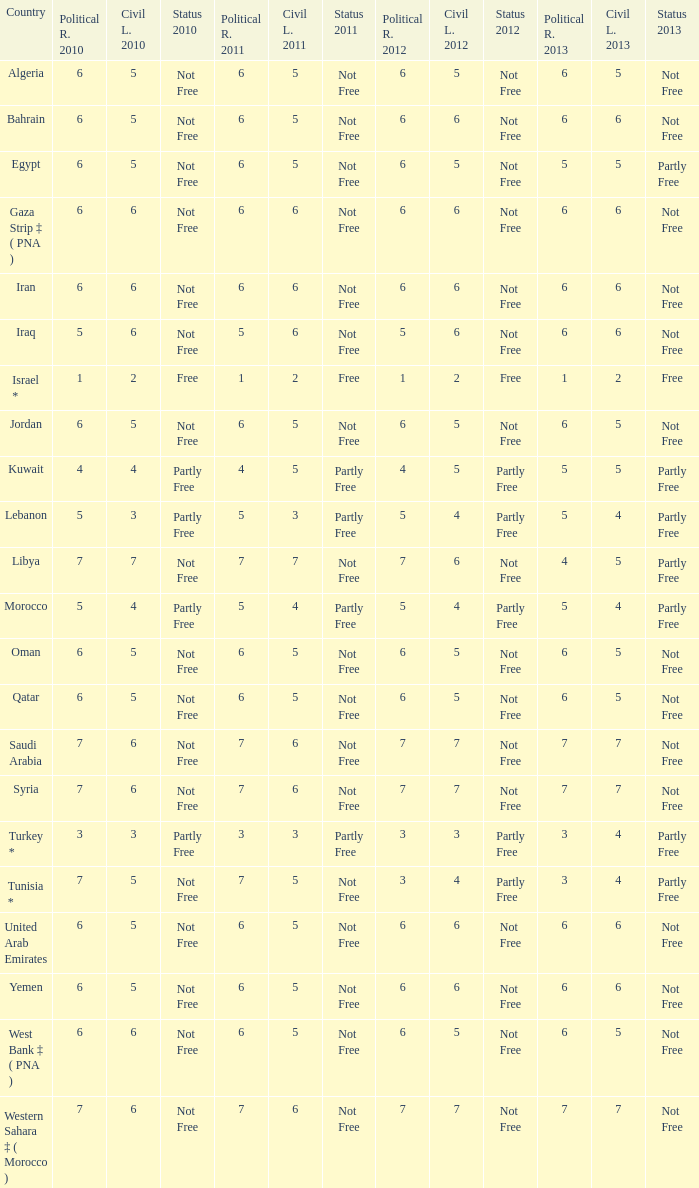What is the average 2012 civil liberties value associated with a 2011 status of not free, political rights 2012 over 6, and political rights 2011 over 7? None. Would you be able to parse every entry in this table? {'header': ['Country', 'Political R. 2010', 'Civil L. 2010', 'Status 2010', 'Political R. 2011', 'Civil L. 2011', 'Status 2011', 'Political R. 2012', 'Civil L. 2012', 'Status 2012', 'Political R. 2013', 'Civil L. 2013', 'Status 2013'], 'rows': [['Algeria', '6', '5', 'Not Free', '6', '5', 'Not Free', '6', '5', 'Not Free', '6', '5', 'Not Free'], ['Bahrain', '6', '5', 'Not Free', '6', '5', 'Not Free', '6', '6', 'Not Free', '6', '6', 'Not Free'], ['Egypt', '6', '5', 'Not Free', '6', '5', 'Not Free', '6', '5', 'Not Free', '5', '5', 'Partly Free'], ['Gaza Strip ‡ ( PNA )', '6', '6', 'Not Free', '6', '6', 'Not Free', '6', '6', 'Not Free', '6', '6', 'Not Free'], ['Iran', '6', '6', 'Not Free', '6', '6', 'Not Free', '6', '6', 'Not Free', '6', '6', 'Not Free'], ['Iraq', '5', '6', 'Not Free', '5', '6', 'Not Free', '5', '6', 'Not Free', '6', '6', 'Not Free'], ['Israel *', '1', '2', 'Free', '1', '2', 'Free', '1', '2', 'Free', '1', '2', 'Free'], ['Jordan', '6', '5', 'Not Free', '6', '5', 'Not Free', '6', '5', 'Not Free', '6', '5', 'Not Free'], ['Kuwait', '4', '4', 'Partly Free', '4', '5', 'Partly Free', '4', '5', 'Partly Free', '5', '5', 'Partly Free'], ['Lebanon', '5', '3', 'Partly Free', '5', '3', 'Partly Free', '5', '4', 'Partly Free', '5', '4', 'Partly Free'], ['Libya', '7', '7', 'Not Free', '7', '7', 'Not Free', '7', '6', 'Not Free', '4', '5', 'Partly Free'], ['Morocco', '5', '4', 'Partly Free', '5', '4', 'Partly Free', '5', '4', 'Partly Free', '5', '4', 'Partly Free'], ['Oman', '6', '5', 'Not Free', '6', '5', 'Not Free', '6', '5', 'Not Free', '6', '5', 'Not Free'], ['Qatar', '6', '5', 'Not Free', '6', '5', 'Not Free', '6', '5', 'Not Free', '6', '5', 'Not Free'], ['Saudi Arabia', '7', '6', 'Not Free', '7', '6', 'Not Free', '7', '7', 'Not Free', '7', '7', 'Not Free'], ['Syria', '7', '6', 'Not Free', '7', '6', 'Not Free', '7', '7', 'Not Free', '7', '7', 'Not Free'], ['Turkey *', '3', '3', 'Partly Free', '3', '3', 'Partly Free', '3', '3', 'Partly Free', '3', '4', 'Partly Free'], ['Tunisia *', '7', '5', 'Not Free', '7', '5', 'Not Free', '3', '4', 'Partly Free', '3', '4', 'Partly Free'], ['United Arab Emirates', '6', '5', 'Not Free', '6', '5', 'Not Free', '6', '6', 'Not Free', '6', '6', 'Not Free'], ['Yemen', '6', '5', 'Not Free', '6', '5', 'Not Free', '6', '6', 'Not Free', '6', '6', 'Not Free'], ['West Bank ‡ ( PNA )', '6', '6', 'Not Free', '6', '5', 'Not Free', '6', '5', 'Not Free', '6', '5', 'Not Free'], ['Western Sahara ‡ ( Morocco )', '7', '6', 'Not Free', '7', '6', 'Not Free', '7', '7', 'Not Free', '7', '7', 'Not Free']]} 